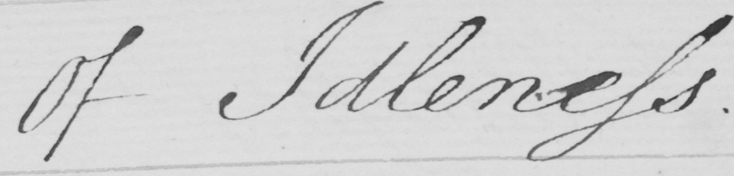Please transcribe the handwritten text in this image. Of Idleness . 